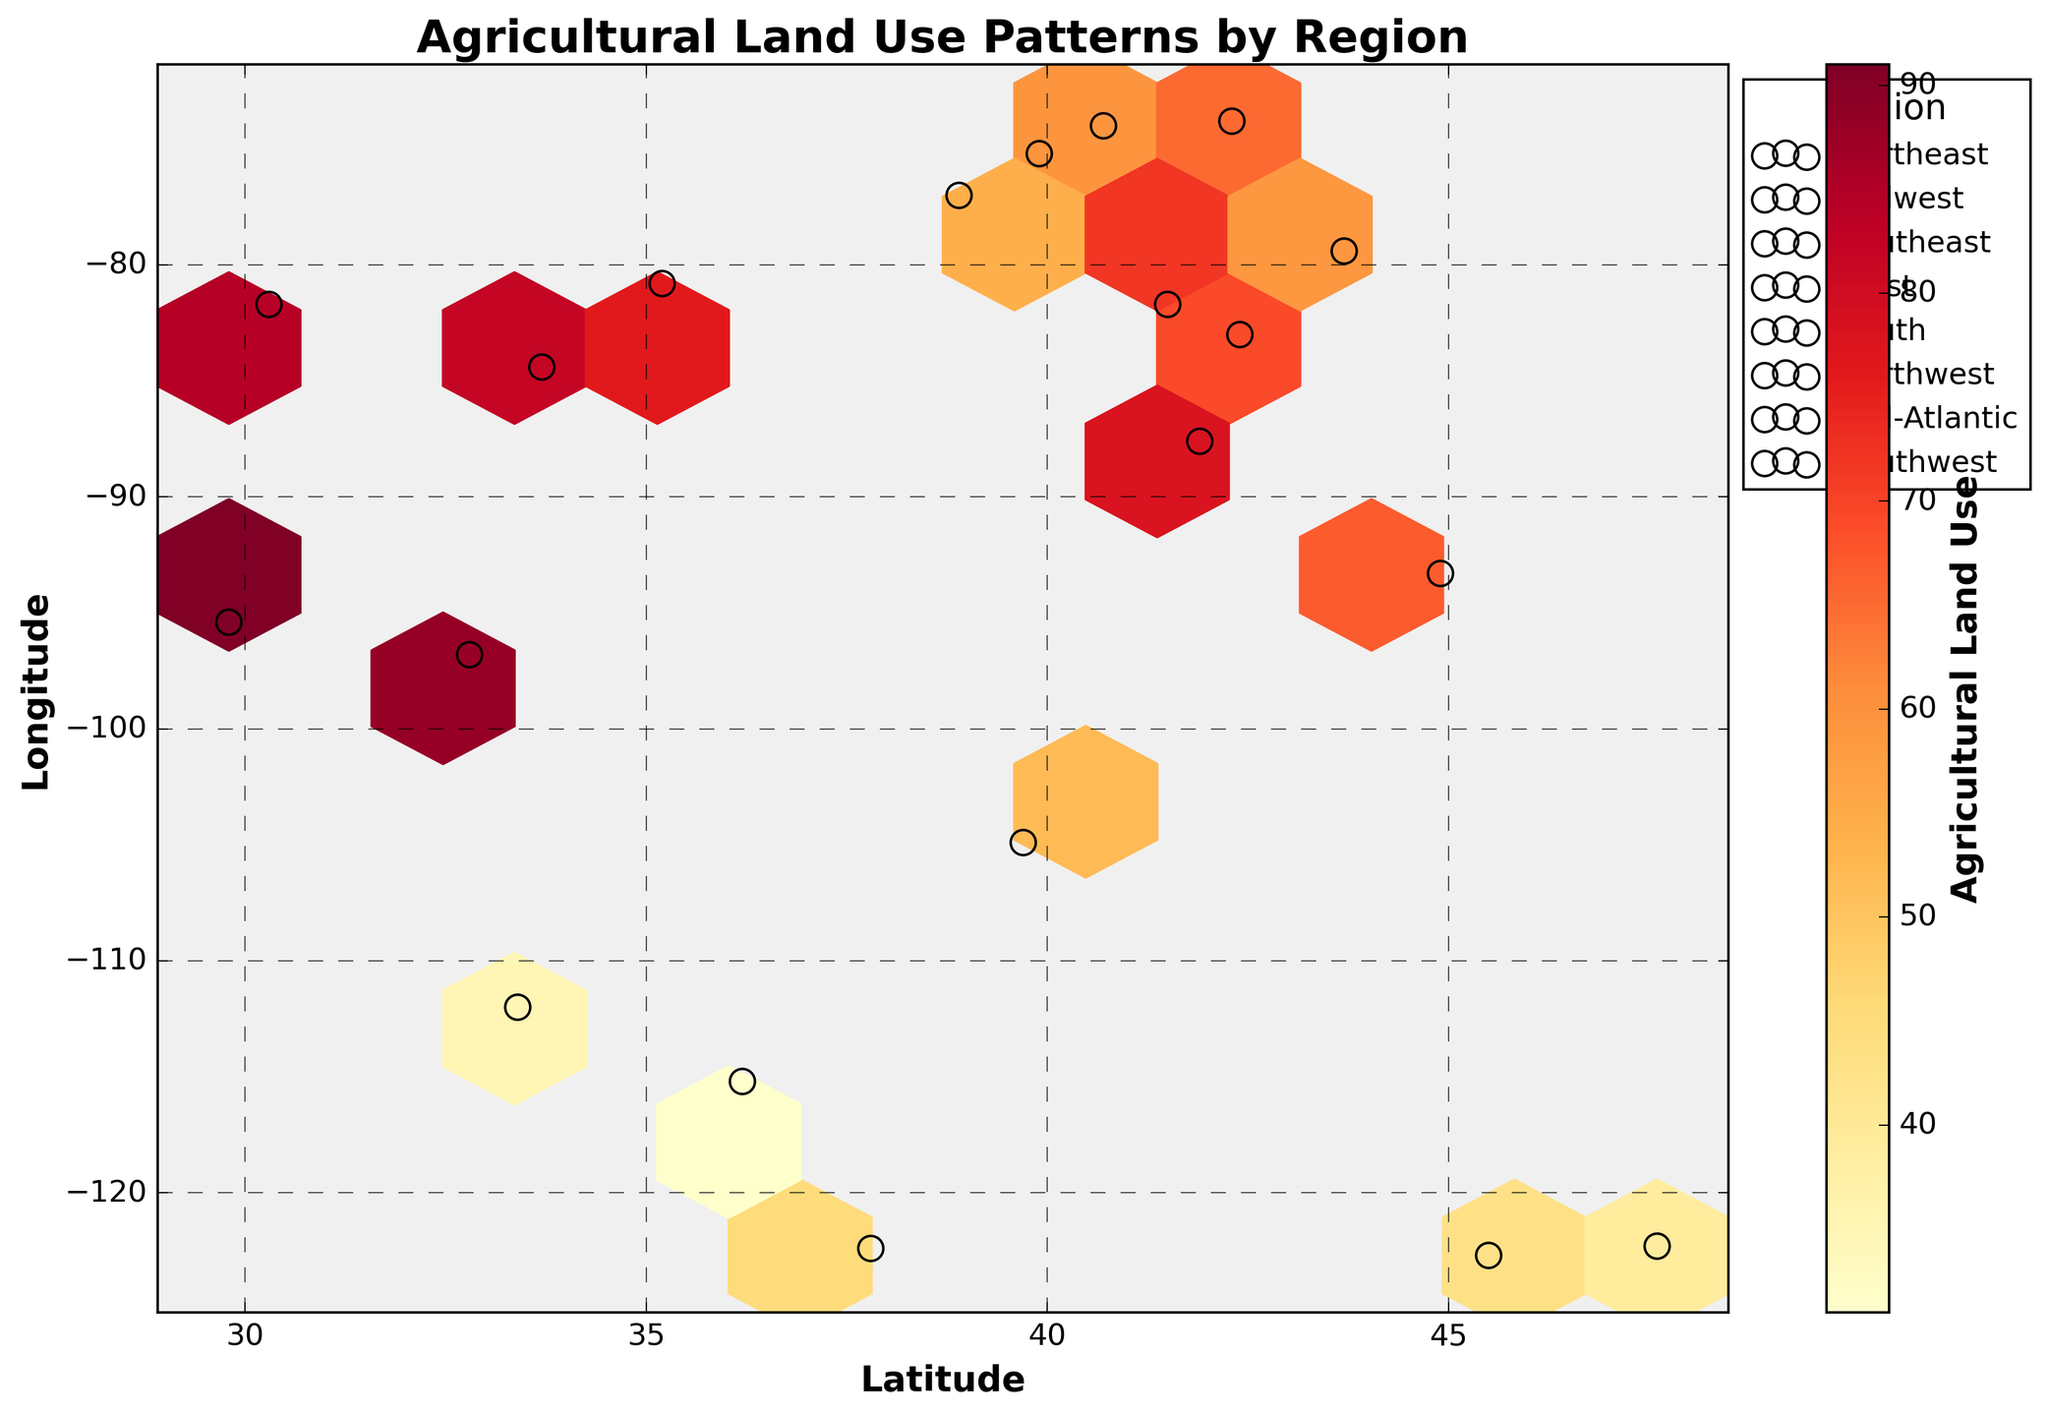What's the title of the hexbin plot? The title of the plot is displayed prominently at the top and provides an overview of the dataset being visualized. The title is "Agricultural Land Use Patterns by Region".
Answer: Agricultural Land Use Patterns by Region What does the color represent in this hexbin plot? The color in the hexbin plot represents the intensity of agricultural land use. Darker colors indicate higher values.
Answer: Agricultural Land Use What are the axes labels of the plot? The x-axis and y-axis labels provide context to the values being plotted. The x-axis label is "Latitude", and the y-axis label is "Longitude".
Answer: Latitude and Longitude How many regions are represented in the plot? By looking at the legend on the right side of the plot, we can count the number of different regions indicated. There are 7 unique regions represented.
Answer: 7 Which region has the highest agricultural land use value? Observing the marked points and matching with the legend, the region with the highest single data point has a value of 91, represented in the 'South' region.
Answer: South Which region has the lowest agricultural land use value? The region with the lowest single data point, which is 31, falls within the 'Southwest' region, based on the scatter points and their corresponding labels.
Answer: Southwest Compare agricultural land use between the Midwest and Northwest regions. Which one has a higher average value? Summing up the values for each region, Midwest: (78 + 72 + 69 + 67 = 286), for 4 points. Northwest: (39 + 43 = 82), for 2 points. The average for Midwest is 286/4 = 71.5, whereas for the Northwest it is 82/2 = 41. So, Midwest has a higher average value.
Answer: Midwest Which two regions are located closest in geographic space based on their latitude and longitude? Observing the scatter points and their coordinates, the two regions geographically closest are 'West' and 'Southwest', centered around longitude -112 to -122 and latitudes 33 to 36.
Answer: West and Southwest What is the range of agricultural land use values in the Southeast region? Observing the values for the Southeast region points: (82, 76, 84). The range is the difference between the highest and lowest values: 84 - 76 = 8.
Answer: 8 